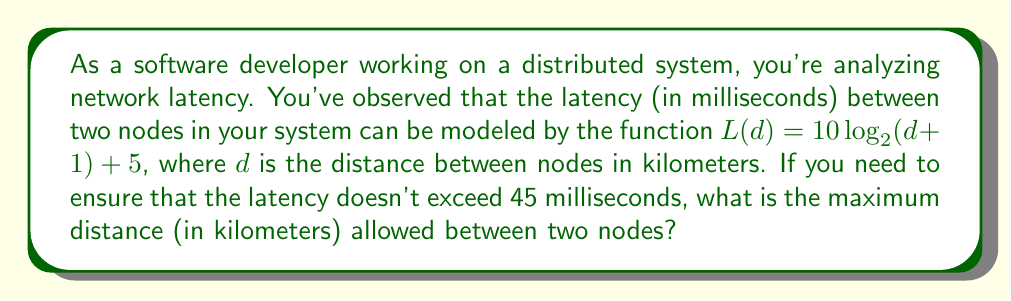Provide a solution to this math problem. To solve this problem, we need to use the given logarithmic function and work backwards to find the maximum distance. Let's approach this step-by-step:

1) We start with the given function: $L(d) = 10 \log_2(d + 1) + 5$

2) We want to find $d$ when $L(d) = 45$ (the maximum allowed latency):

   $45 = 10 \log_2(d + 1) + 5$

3) Subtract 5 from both sides:

   $40 = 10 \log_2(d + 1)$

4) Divide both sides by 10:

   $4 = \log_2(d + 1)$

5) Now, we need to solve for $d$. We can do this by applying $2^x$ to both sides:

   $2^4 = 2^{\log_2(d + 1)}$

6) The right side simplifies to just $(d + 1)$ because $2^{\log_2(x)} = x$:

   $16 = d + 1$

7) Subtract 1 from both sides:

   $15 = d$

Therefore, the maximum distance allowed between two nodes is 15 kilometers.
Answer: 15 kilometers 